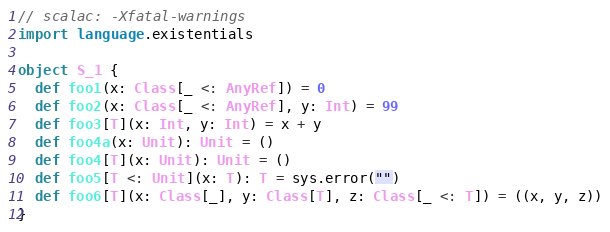Convert code to text. <code><loc_0><loc_0><loc_500><loc_500><_Scala_>// scalac: -Xfatal-warnings
import language.existentials

object S_1 {
  def foo1(x: Class[_ <: AnyRef]) = 0
  def foo2(x: Class[_ <: AnyRef], y: Int) = 99
  def foo3[T](x: Int, y: Int) = x + y
  def foo4a(x: Unit): Unit = ()
  def foo4[T](x: Unit): Unit = ()
  def foo5[T <: Unit](x: T): T = sys.error("")
  def foo6[T](x: Class[_], y: Class[T], z: Class[_ <: T]) = ((x, y, z))
}
</code> 